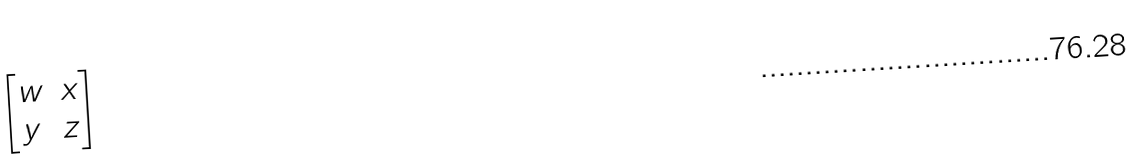<formula> <loc_0><loc_0><loc_500><loc_500>\begin{bmatrix} w & x \\ y & z \\ \end{bmatrix}</formula> 